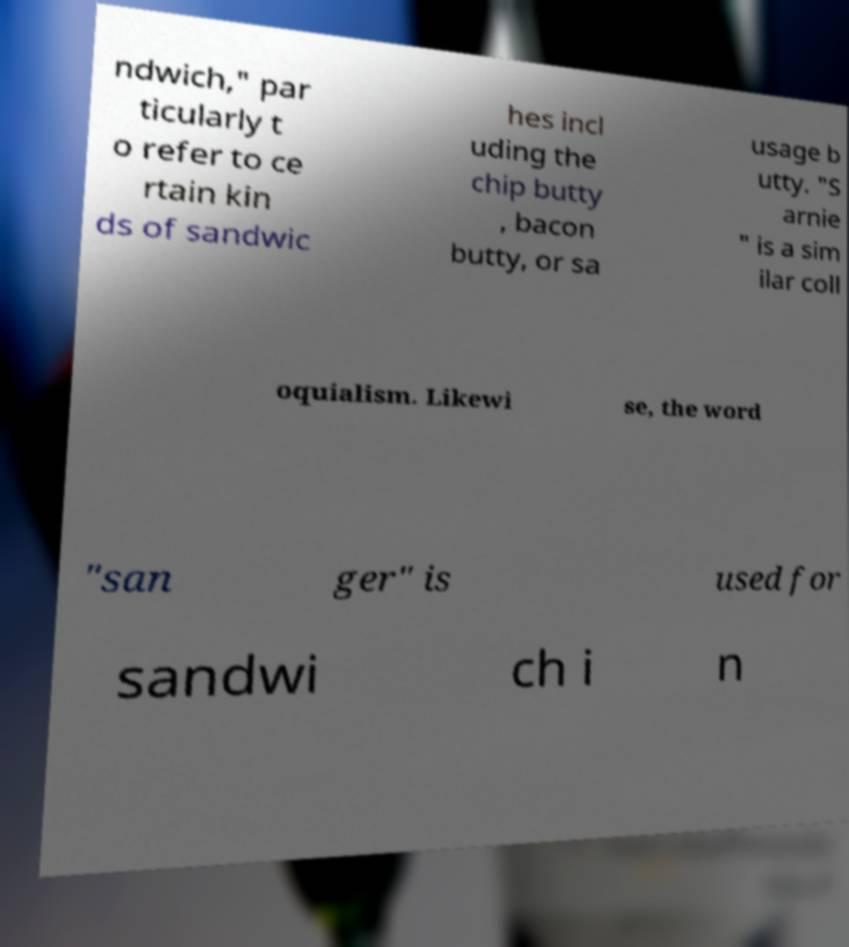Can you read and provide the text displayed in the image?This photo seems to have some interesting text. Can you extract and type it out for me? ndwich," par ticularly t o refer to ce rtain kin ds of sandwic hes incl uding the chip butty , bacon butty, or sa usage b utty. "S arnie " is a sim ilar coll oquialism. Likewi se, the word "san ger" is used for sandwi ch i n 